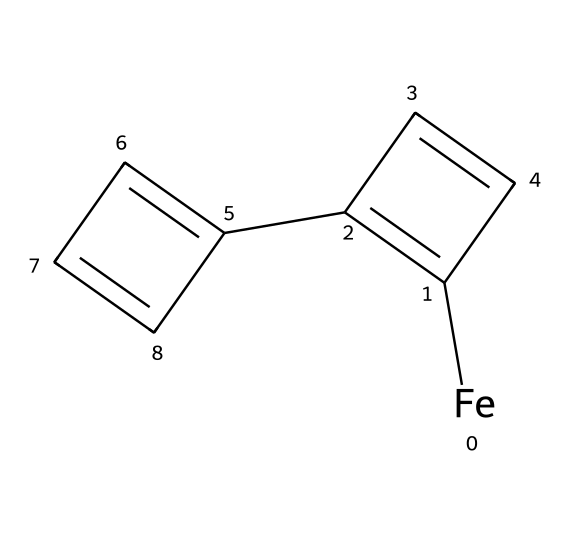What is the central metal in ferrocene? The chemical structure shows an iron atom, which is indicated by the [Fe] notation in the SMILES representation. This identifies iron as the central metal in the organometallic compound.
Answer: iron How many cyclopentadienyl rings are present in ferrocene? Analyzing the structure, we can see two distinct cyclopentadienyl rings (represented by the ‘C1=C(...)’ and ‘C2=CC(...)’ in the SMILES), confirming their presence in the molecule.
Answer: 2 What is the hybridization of the iron atom in ferrocene? The iron atom is surrounded by two cyclopentadienyl anions, leading to a coordination number of 6. This arrangement suggests that iron has a hybridization of d2sp3, accommodating its bonding with the two rings.
Answer: d2sp3 What type of bonding exists between iron and the cyclopentadienyl rings? The bonding between the iron and the cyclopentadienyl rings is classified as coordinate covalent bonding, as the cyclopentadienyl rings donate electrons to the iron atom, forming a stable complex.
Answer: coordinate covalent What is the molecular formula of ferrocene? Considering the structure, each cyclopentadienyl ring contributes five carbon atoms and four hydrogen atoms, while there is one iron atom, leading to the molecular formula C10H10Fe.
Answer: C10H10Fe What is the geometric arrangement of ferrocene? The arrangement of ferrocene exhibits an 'sandwich' structure with the planar cyclopentadienyl rings above and below the iron, characterized by a staggered conformation.
Answer: sandwich What is a notable property of ferrocene due to its structure? The structure of ferrocene allows it to act as a well-defined redox couple, which lends itself to unique electrochemical properties, making it useful in electronic materials.
Answer: redox couple 